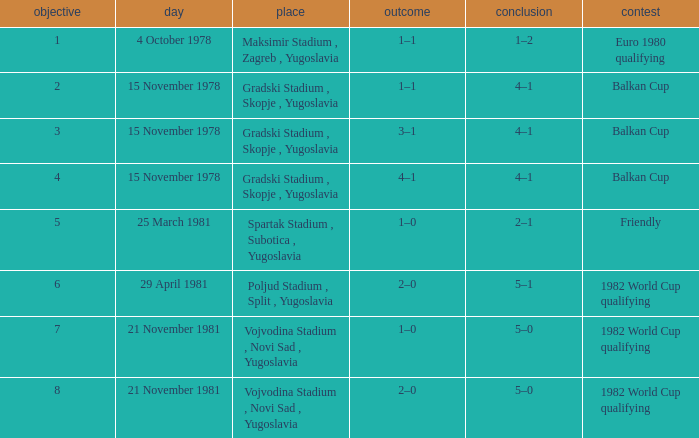What is the Result for Goal 3? 4–1. Parse the full table. {'header': ['objective', 'day', 'place', 'outcome', 'conclusion', 'contest'], 'rows': [['1', '4 October 1978', 'Maksimir Stadium , Zagreb , Yugoslavia', '1–1', '1–2', 'Euro 1980 qualifying'], ['2', '15 November 1978', 'Gradski Stadium , Skopje , Yugoslavia', '1–1', '4–1', 'Balkan Cup'], ['3', '15 November 1978', 'Gradski Stadium , Skopje , Yugoslavia', '3–1', '4–1', 'Balkan Cup'], ['4', '15 November 1978', 'Gradski Stadium , Skopje , Yugoslavia', '4–1', '4–1', 'Balkan Cup'], ['5', '25 March 1981', 'Spartak Stadium , Subotica , Yugoslavia', '1–0', '2–1', 'Friendly'], ['6', '29 April 1981', 'Poljud Stadium , Split , Yugoslavia', '2–0', '5–1', '1982 World Cup qualifying'], ['7', '21 November 1981', 'Vojvodina Stadium , Novi Sad , Yugoslavia', '1–0', '5–0', '1982 World Cup qualifying'], ['8', '21 November 1981', 'Vojvodina Stadium , Novi Sad , Yugoslavia', '2–0', '5–0', '1982 World Cup qualifying']]} 